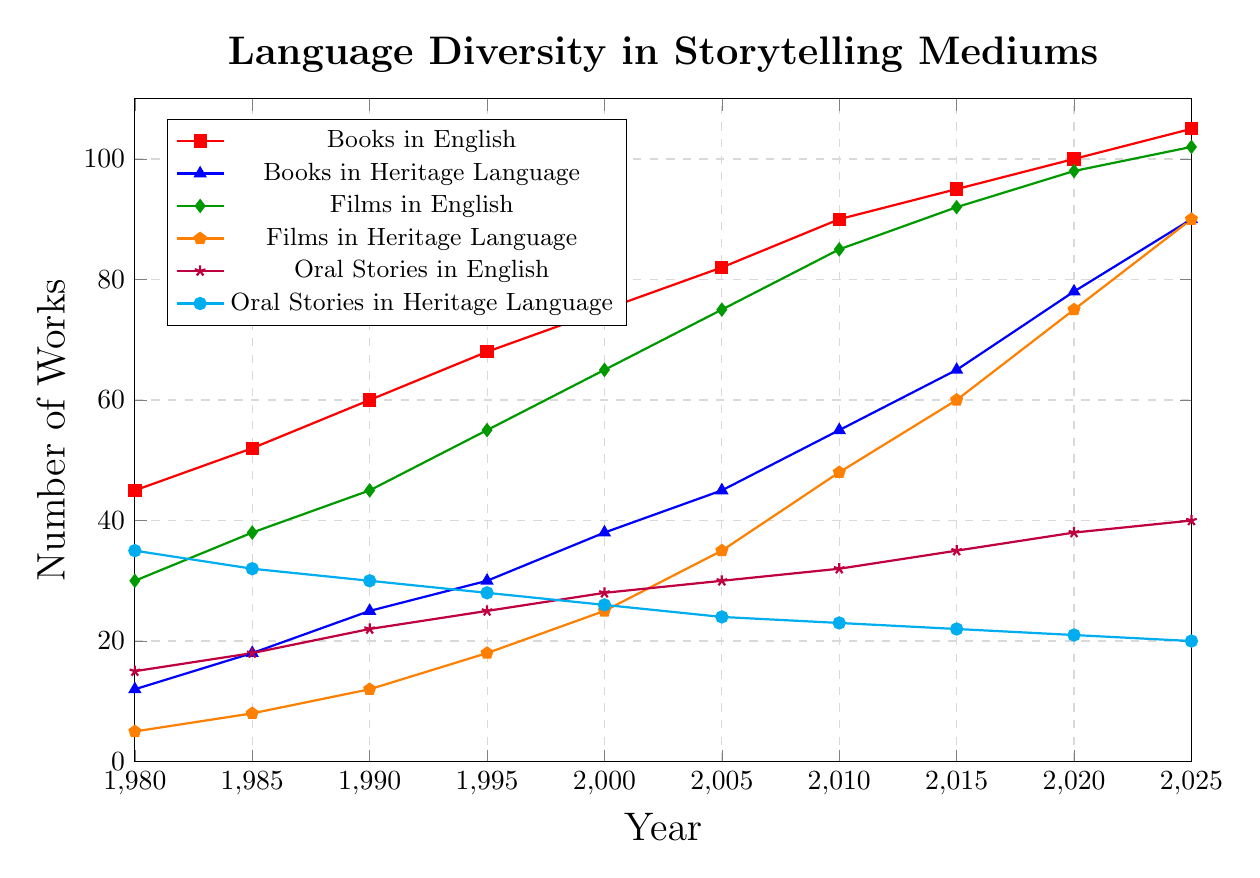What trend do you observe in the number of Books in English from 1980 to 2025? The number of Books in English has steadily increased from 45 in 1980 to 105 in 2025. This indicates a consistent upward trend over the years.
Answer: Steady increase Which storytelling medium in Heritage Language has shown the most significant increase in the number of works from 1980 to 2025? Films in Heritage Language have shown the most significant increase, starting from 5 in 1980 and reaching 90 in 2025. This is a substantial growth of 85 works.
Answer: Films in Heritage Language In which year did Oral Stories in English and Oral Stories in Heritage Language have the closest number of works? In 1985, Oral Stories in English had 18 works, and Oral Stories in Heritage Language had 32 works, with a difference of 14 works, making it the closest year.
Answer: 1985 Calculate the average number of Films in Heritage Language for the years 1990, 1995, and 2000. For 1990: 12, 1995: 18, and 2000: 25. The average is calculated as (12 + 18 + 25) / 3 = 55 / 3 ≈ 18.33.
Answer: 18.33 Compare the number of Books in Heritage Language with the number of Oral Stories in Heritage Language in 2025. Which has more, and by how much? In 2025, there are 90 Books in Heritage Language and 20 Oral Stories in Heritage Language. The difference is 90 - 20 = 70. Books in Heritage Language have more.
Answer: Books in Heritage Language, 70 more What color is used to represent the trend of Films in English in the plot? The color used to represent Films in English in the plot is green.
Answer: green Determine the year with the most significant increase in the number of Films in English between two consecutive data points. The most significant increase occurred between 2010 and 2015, where the number of Films in English increased from 85 to 92, showing a rise of 7 works.
Answer: 2010 to 2015 What is the total number of storytelling works in all mediums in English in the year 2000? In 2000: Books in English (75) + Films in English (65) + Oral Stories in English (28). The total is 75 + 65 + 28 = 168.
Answer: 168 By how much did the number of Oral Stories in Heritage Language decrease from 1980 to 2025? In 1980, the number of Oral Stories in Heritage Language was 35, and in 2025 it is 20. The decrease is 35 - 20 = 15.
Answer: 15 